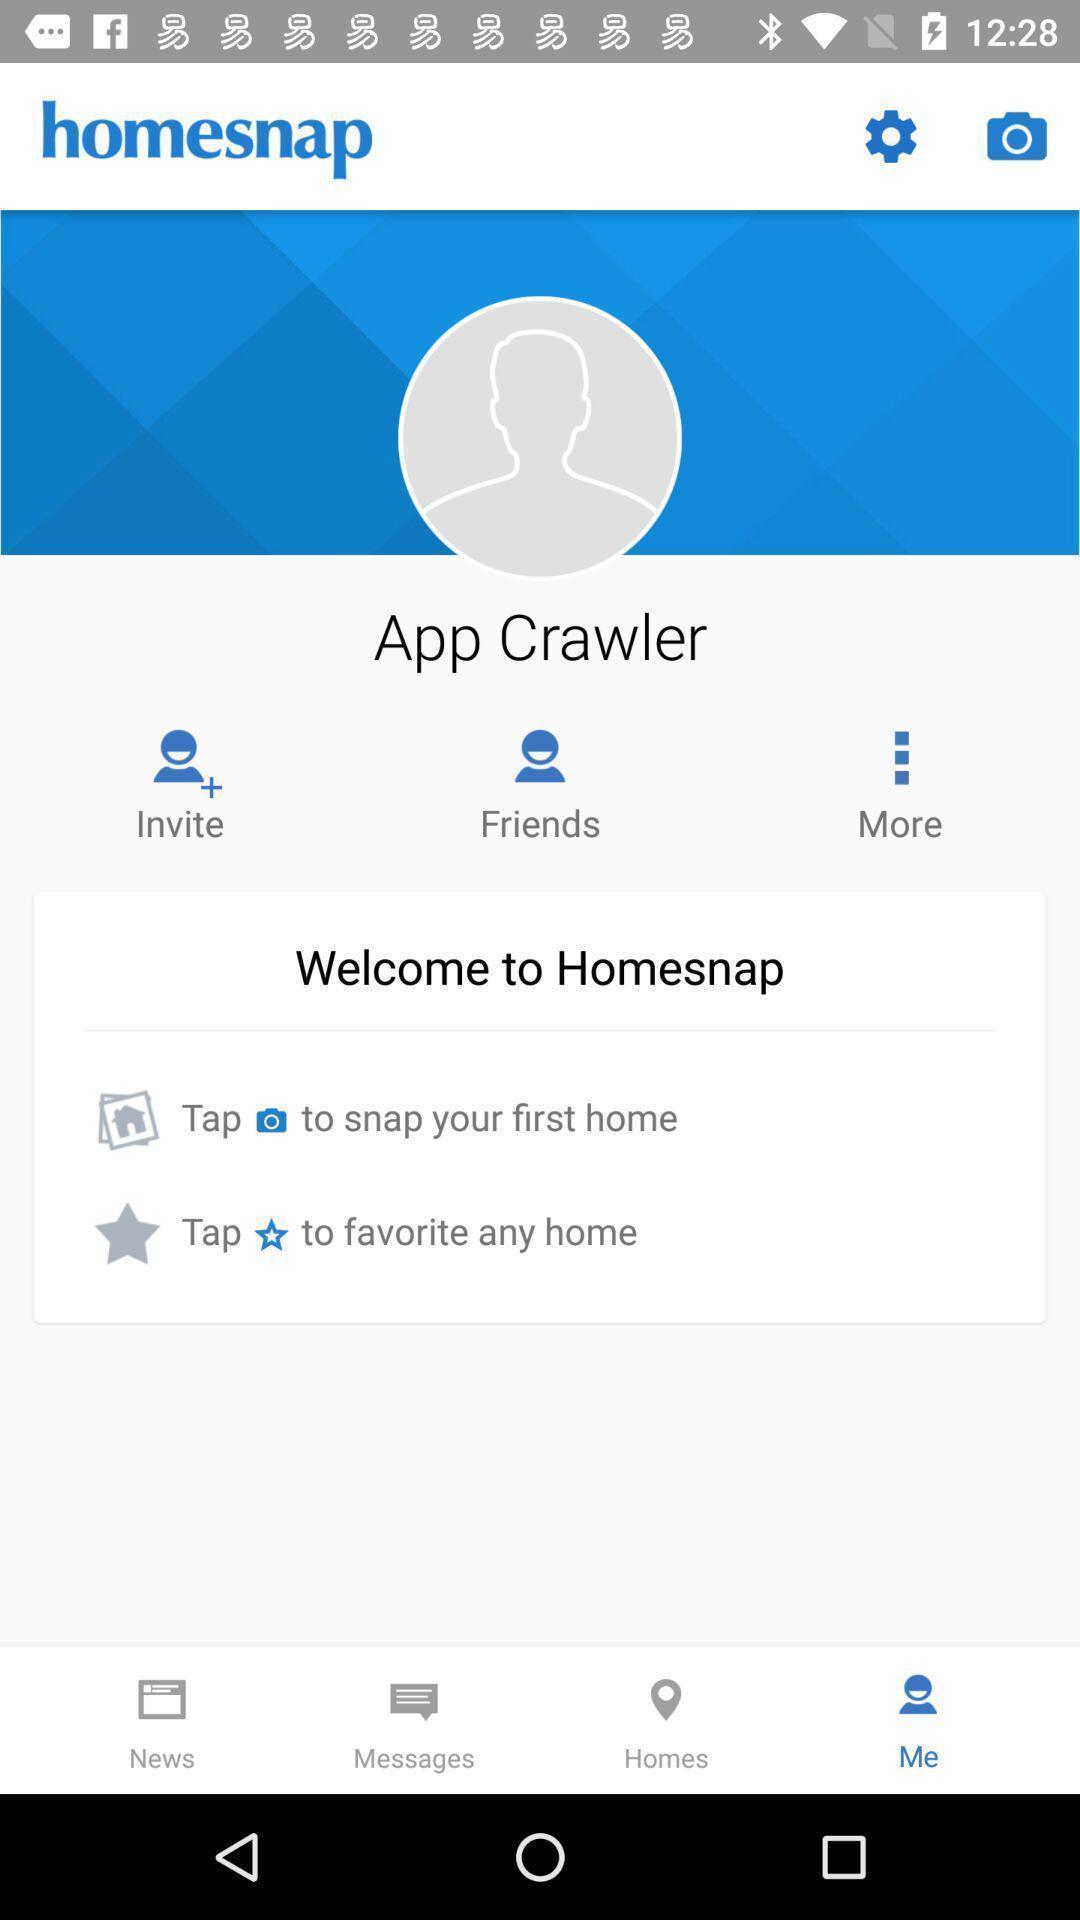Describe the key features of this screenshot. Welcome page. 